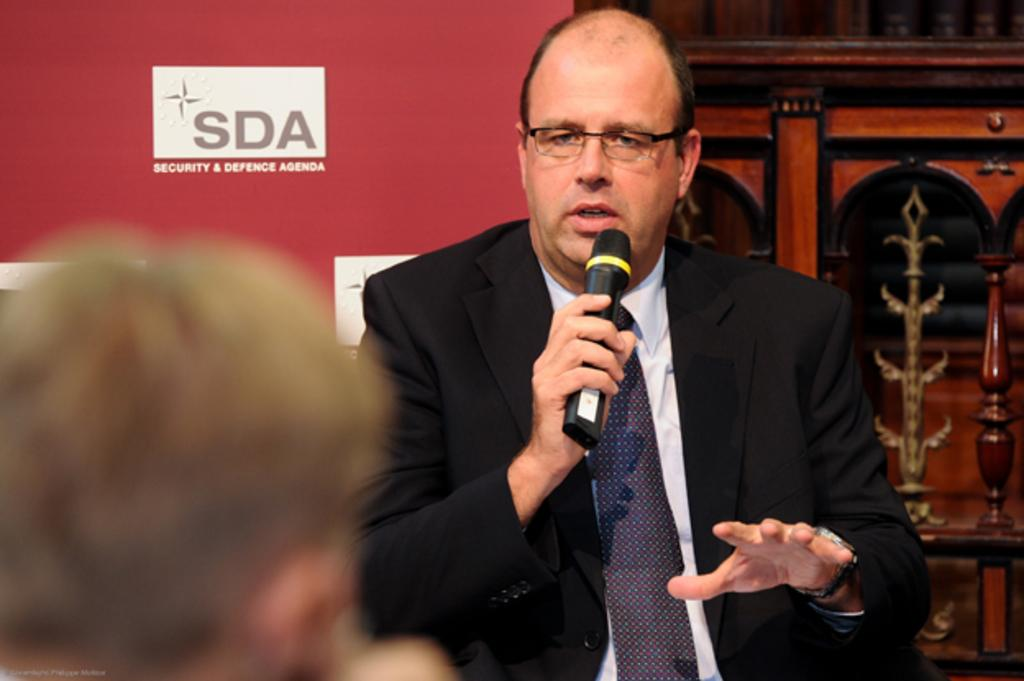Who is the main subject in the image? There is a man in the picture. What is the man doing in the image? The man is standing and speaking. What object is the man holding in his hand? The man is holding a microphone in his hand. What type of underwear is the man wearing in the image? There is no information about the man's underwear in the image, so it cannot be determined. 